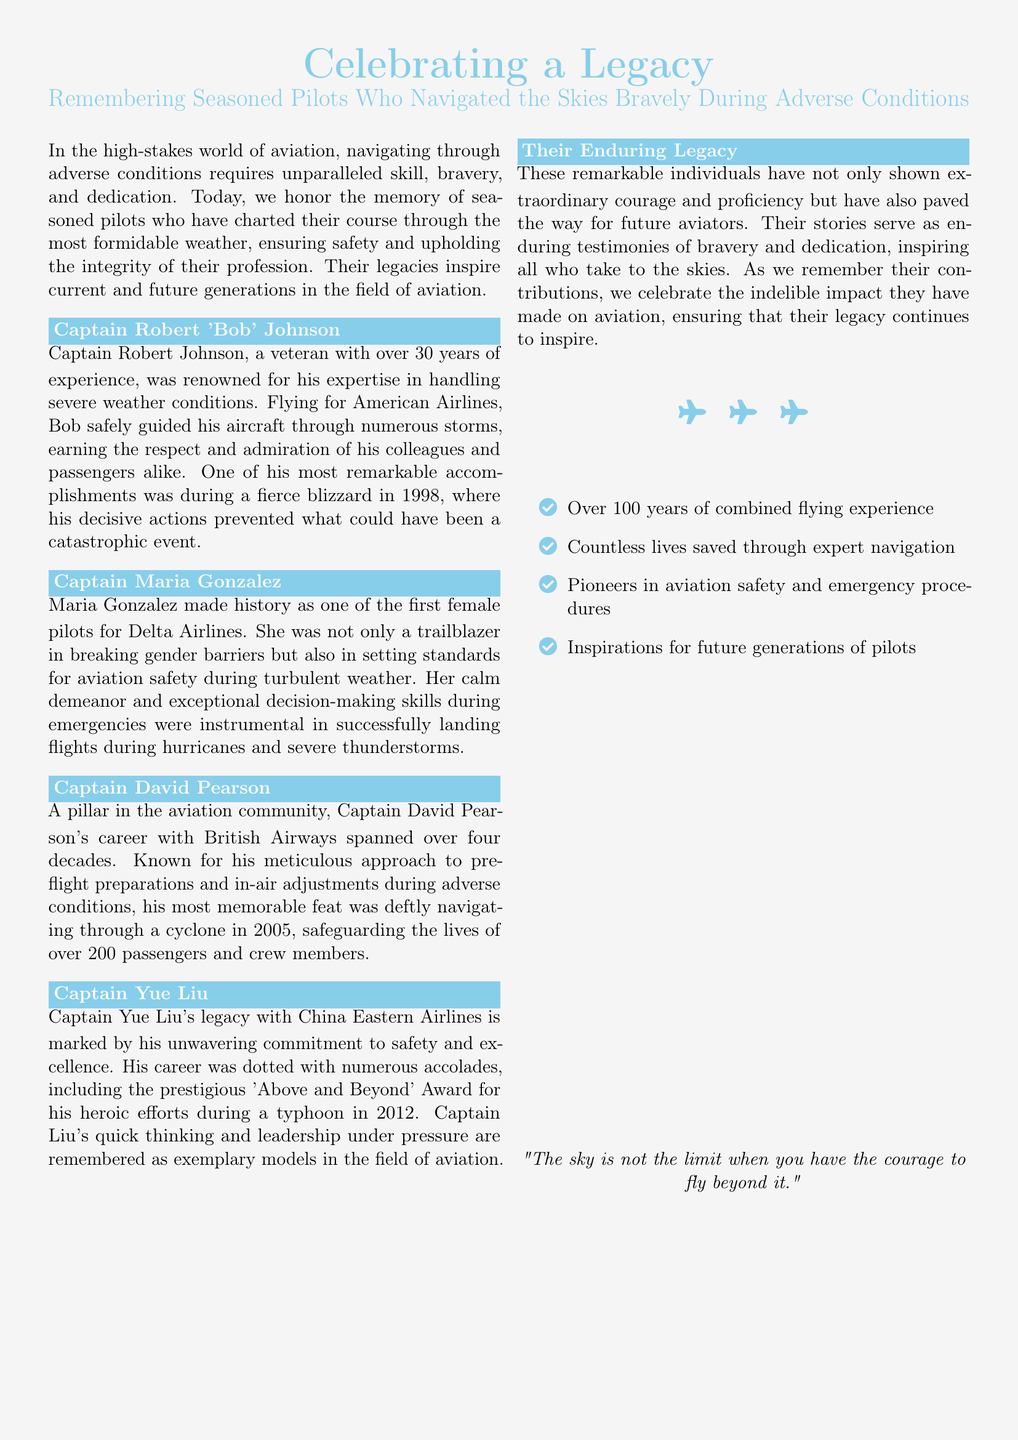What was Captain Robert Johnson known for? Captain Robert Johnson was renowned for his expertise in handling severe weather conditions.
Answer: Expertise in handling severe weather conditions What airline did Captain Maria Gonzalez fly for? Captain Maria Gonzalez made history as one of the first female pilots for Delta Airlines.
Answer: Delta Airlines What year did Captain David Pearson navigate through a cyclone? Captain David Pearson's most memorable feat was deftly navigating through a cyclone in 2005.
Answer: 2005 What award did Captain Yue Liu receive? Captain Yue Liu was honored with the prestigious 'Above and Beyond' Award for his heroic efforts during a typhoon in 2012.
Answer: 'Above and Beyond' Award How many years of combined flying experience is mentioned? The document states over 100 years of combined flying experience.
Answer: Over 100 years What is the main theme of the document? The document is about celebrating the legacy of seasoned pilots who navigated the skies bravely during adverse conditions.
Answer: Celebrating a legacy What phrase is used at the end of the document? The phrase at the end of the document is "The sky is not the limit when you have the courage to fly beyond it."
Answer: The sky is not the limit when you have the courage to fly beyond it How many pilots are specifically honored in the document? The document specifically honors four pilots: Captain Robert Johnson, Captain Maria Gonzalez, Captain David Pearson, and Captain Yue Liu.
Answer: Four pilots 